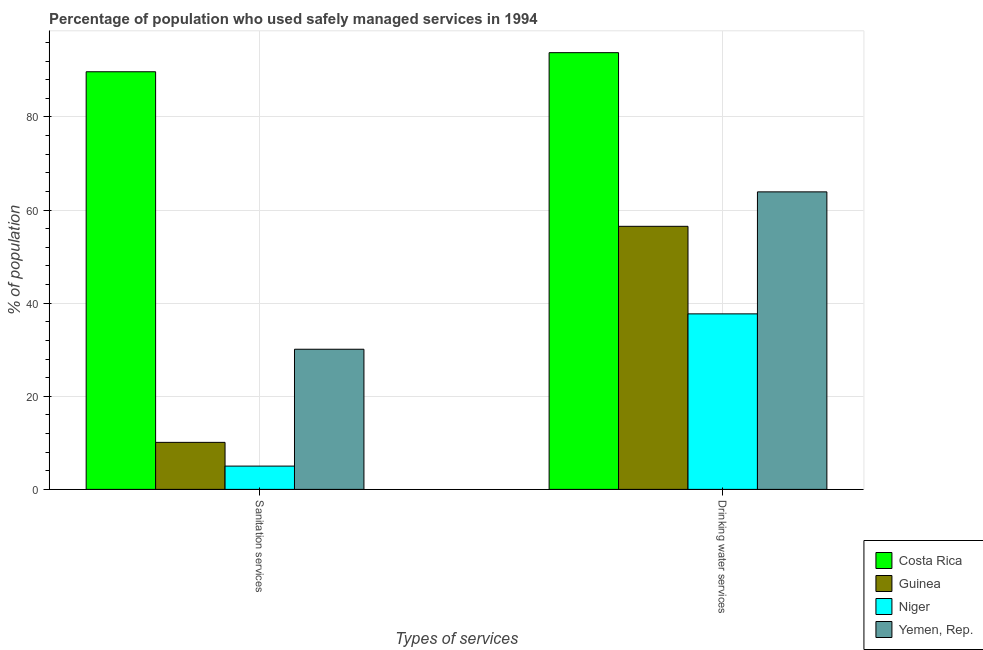How many different coloured bars are there?
Provide a short and direct response. 4. How many groups of bars are there?
Offer a terse response. 2. Are the number of bars on each tick of the X-axis equal?
Offer a terse response. Yes. How many bars are there on the 2nd tick from the left?
Offer a terse response. 4. How many bars are there on the 2nd tick from the right?
Provide a short and direct response. 4. What is the label of the 1st group of bars from the left?
Keep it short and to the point. Sanitation services. What is the percentage of population who used sanitation services in Yemen, Rep.?
Provide a succinct answer. 30.1. Across all countries, what is the maximum percentage of population who used drinking water services?
Provide a short and direct response. 93.8. Across all countries, what is the minimum percentage of population who used drinking water services?
Your answer should be very brief. 37.7. In which country was the percentage of population who used drinking water services maximum?
Keep it short and to the point. Costa Rica. In which country was the percentage of population who used drinking water services minimum?
Your answer should be very brief. Niger. What is the total percentage of population who used drinking water services in the graph?
Keep it short and to the point. 251.9. What is the difference between the percentage of population who used drinking water services in Yemen, Rep. and that in Guinea?
Give a very brief answer. 7.4. What is the difference between the percentage of population who used drinking water services in Costa Rica and the percentage of population who used sanitation services in Yemen, Rep.?
Your answer should be compact. 63.7. What is the average percentage of population who used sanitation services per country?
Offer a very short reply. 33.73. What is the difference between the percentage of population who used sanitation services and percentage of population who used drinking water services in Niger?
Offer a terse response. -32.7. In how many countries, is the percentage of population who used sanitation services greater than 40 %?
Offer a terse response. 1. What is the ratio of the percentage of population who used sanitation services in Niger to that in Costa Rica?
Your answer should be very brief. 0.06. What does the 1st bar from the left in Drinking water services represents?
Give a very brief answer. Costa Rica. How many bars are there?
Your answer should be compact. 8. What is the difference between two consecutive major ticks on the Y-axis?
Offer a terse response. 20. Does the graph contain any zero values?
Your answer should be compact. No. Does the graph contain grids?
Give a very brief answer. Yes. Where does the legend appear in the graph?
Your answer should be very brief. Bottom right. How are the legend labels stacked?
Your response must be concise. Vertical. What is the title of the graph?
Offer a terse response. Percentage of population who used safely managed services in 1994. Does "Bahamas" appear as one of the legend labels in the graph?
Provide a short and direct response. No. What is the label or title of the X-axis?
Provide a succinct answer. Types of services. What is the label or title of the Y-axis?
Make the answer very short. % of population. What is the % of population in Costa Rica in Sanitation services?
Make the answer very short. 89.7. What is the % of population of Guinea in Sanitation services?
Provide a succinct answer. 10.1. What is the % of population in Niger in Sanitation services?
Give a very brief answer. 5. What is the % of population in Yemen, Rep. in Sanitation services?
Offer a terse response. 30.1. What is the % of population in Costa Rica in Drinking water services?
Your response must be concise. 93.8. What is the % of population of Guinea in Drinking water services?
Your answer should be compact. 56.5. What is the % of population in Niger in Drinking water services?
Give a very brief answer. 37.7. What is the % of population of Yemen, Rep. in Drinking water services?
Your answer should be very brief. 63.9. Across all Types of services, what is the maximum % of population in Costa Rica?
Your answer should be compact. 93.8. Across all Types of services, what is the maximum % of population in Guinea?
Offer a very short reply. 56.5. Across all Types of services, what is the maximum % of population of Niger?
Offer a very short reply. 37.7. Across all Types of services, what is the maximum % of population of Yemen, Rep.?
Ensure brevity in your answer.  63.9. Across all Types of services, what is the minimum % of population in Costa Rica?
Give a very brief answer. 89.7. Across all Types of services, what is the minimum % of population of Niger?
Offer a terse response. 5. Across all Types of services, what is the minimum % of population in Yemen, Rep.?
Offer a terse response. 30.1. What is the total % of population of Costa Rica in the graph?
Offer a terse response. 183.5. What is the total % of population in Guinea in the graph?
Your answer should be compact. 66.6. What is the total % of population of Niger in the graph?
Provide a succinct answer. 42.7. What is the total % of population in Yemen, Rep. in the graph?
Your answer should be very brief. 94. What is the difference between the % of population in Costa Rica in Sanitation services and that in Drinking water services?
Keep it short and to the point. -4.1. What is the difference between the % of population in Guinea in Sanitation services and that in Drinking water services?
Provide a succinct answer. -46.4. What is the difference between the % of population in Niger in Sanitation services and that in Drinking water services?
Ensure brevity in your answer.  -32.7. What is the difference between the % of population of Yemen, Rep. in Sanitation services and that in Drinking water services?
Your response must be concise. -33.8. What is the difference between the % of population of Costa Rica in Sanitation services and the % of population of Guinea in Drinking water services?
Make the answer very short. 33.2. What is the difference between the % of population of Costa Rica in Sanitation services and the % of population of Niger in Drinking water services?
Your answer should be compact. 52. What is the difference between the % of population of Costa Rica in Sanitation services and the % of population of Yemen, Rep. in Drinking water services?
Your answer should be compact. 25.8. What is the difference between the % of population of Guinea in Sanitation services and the % of population of Niger in Drinking water services?
Offer a very short reply. -27.6. What is the difference between the % of population in Guinea in Sanitation services and the % of population in Yemen, Rep. in Drinking water services?
Give a very brief answer. -53.8. What is the difference between the % of population in Niger in Sanitation services and the % of population in Yemen, Rep. in Drinking water services?
Your answer should be compact. -58.9. What is the average % of population in Costa Rica per Types of services?
Provide a succinct answer. 91.75. What is the average % of population of Guinea per Types of services?
Your answer should be compact. 33.3. What is the average % of population in Niger per Types of services?
Provide a succinct answer. 21.35. What is the average % of population of Yemen, Rep. per Types of services?
Offer a very short reply. 47. What is the difference between the % of population in Costa Rica and % of population in Guinea in Sanitation services?
Keep it short and to the point. 79.6. What is the difference between the % of population in Costa Rica and % of population in Niger in Sanitation services?
Offer a terse response. 84.7. What is the difference between the % of population in Costa Rica and % of population in Yemen, Rep. in Sanitation services?
Keep it short and to the point. 59.6. What is the difference between the % of population of Guinea and % of population of Niger in Sanitation services?
Give a very brief answer. 5.1. What is the difference between the % of population in Guinea and % of population in Yemen, Rep. in Sanitation services?
Make the answer very short. -20. What is the difference between the % of population of Niger and % of population of Yemen, Rep. in Sanitation services?
Offer a very short reply. -25.1. What is the difference between the % of population in Costa Rica and % of population in Guinea in Drinking water services?
Give a very brief answer. 37.3. What is the difference between the % of population of Costa Rica and % of population of Niger in Drinking water services?
Offer a very short reply. 56.1. What is the difference between the % of population in Costa Rica and % of population in Yemen, Rep. in Drinking water services?
Offer a terse response. 29.9. What is the difference between the % of population in Niger and % of population in Yemen, Rep. in Drinking water services?
Give a very brief answer. -26.2. What is the ratio of the % of population in Costa Rica in Sanitation services to that in Drinking water services?
Your response must be concise. 0.96. What is the ratio of the % of population of Guinea in Sanitation services to that in Drinking water services?
Offer a very short reply. 0.18. What is the ratio of the % of population in Niger in Sanitation services to that in Drinking water services?
Your answer should be very brief. 0.13. What is the ratio of the % of population in Yemen, Rep. in Sanitation services to that in Drinking water services?
Give a very brief answer. 0.47. What is the difference between the highest and the second highest % of population of Guinea?
Your answer should be very brief. 46.4. What is the difference between the highest and the second highest % of population of Niger?
Make the answer very short. 32.7. What is the difference between the highest and the second highest % of population in Yemen, Rep.?
Your answer should be very brief. 33.8. What is the difference between the highest and the lowest % of population of Guinea?
Keep it short and to the point. 46.4. What is the difference between the highest and the lowest % of population in Niger?
Keep it short and to the point. 32.7. What is the difference between the highest and the lowest % of population of Yemen, Rep.?
Offer a terse response. 33.8. 